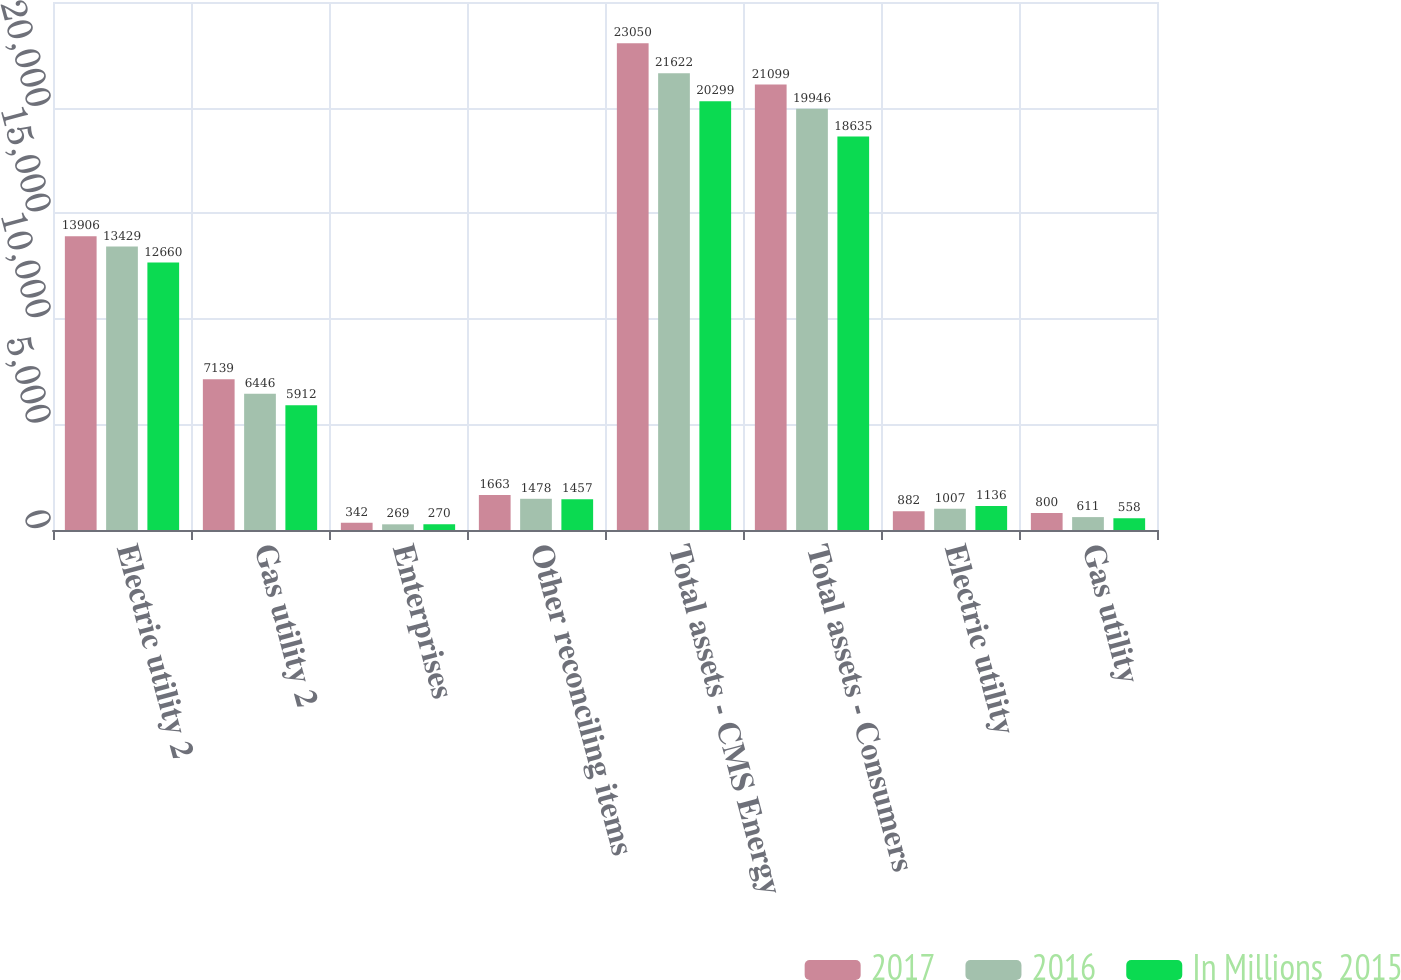Convert chart. <chart><loc_0><loc_0><loc_500><loc_500><stacked_bar_chart><ecel><fcel>Electric utility 2<fcel>Gas utility 2<fcel>Enterprises<fcel>Other reconciling items<fcel>Total assets - CMS Energy<fcel>Total assets - Consumers<fcel>Electric utility<fcel>Gas utility<nl><fcel>2017<fcel>13906<fcel>7139<fcel>342<fcel>1663<fcel>23050<fcel>21099<fcel>882<fcel>800<nl><fcel>2016<fcel>13429<fcel>6446<fcel>269<fcel>1478<fcel>21622<fcel>19946<fcel>1007<fcel>611<nl><fcel>In Millions  2015<fcel>12660<fcel>5912<fcel>270<fcel>1457<fcel>20299<fcel>18635<fcel>1136<fcel>558<nl></chart> 